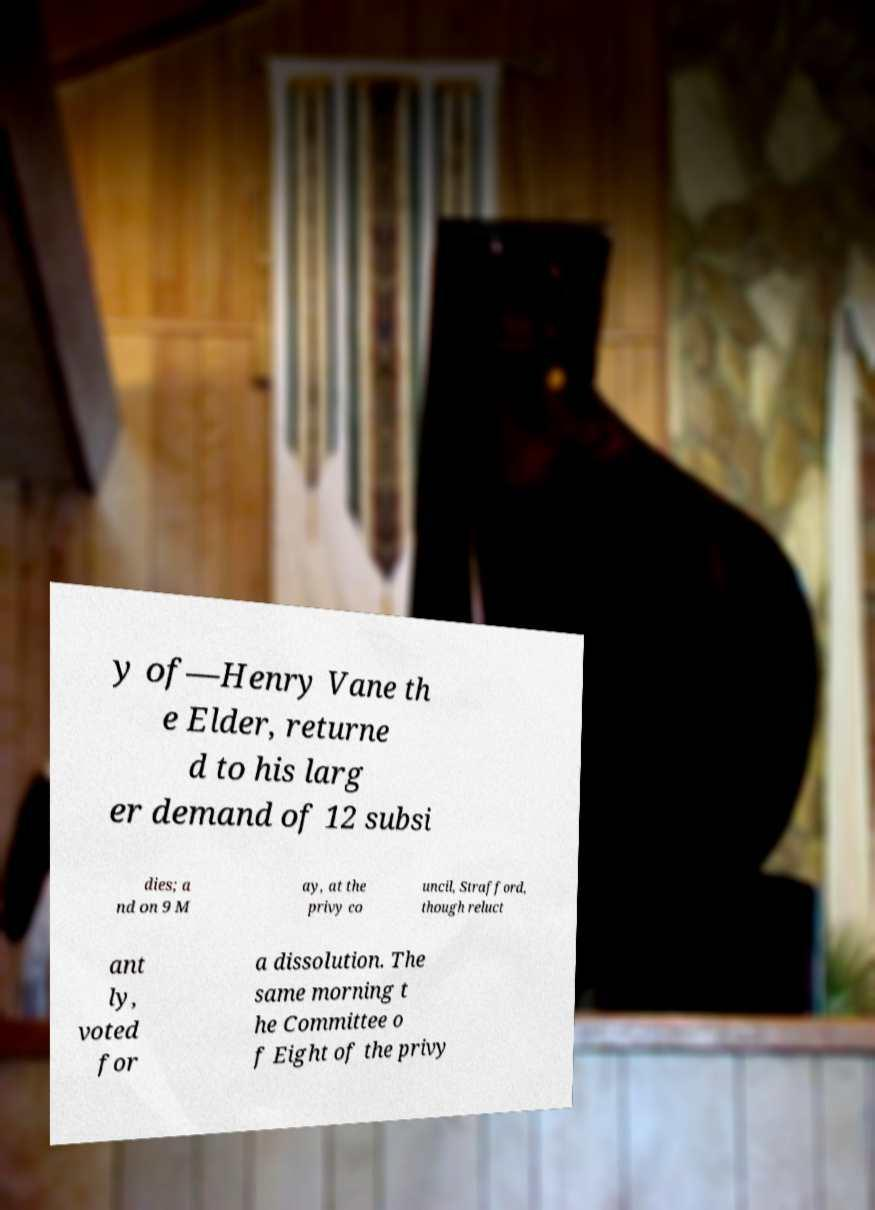Could you extract and type out the text from this image? y of—Henry Vane th e Elder, returne d to his larg er demand of 12 subsi dies; a nd on 9 M ay, at the privy co uncil, Strafford, though reluct ant ly, voted for a dissolution. The same morning t he Committee o f Eight of the privy 